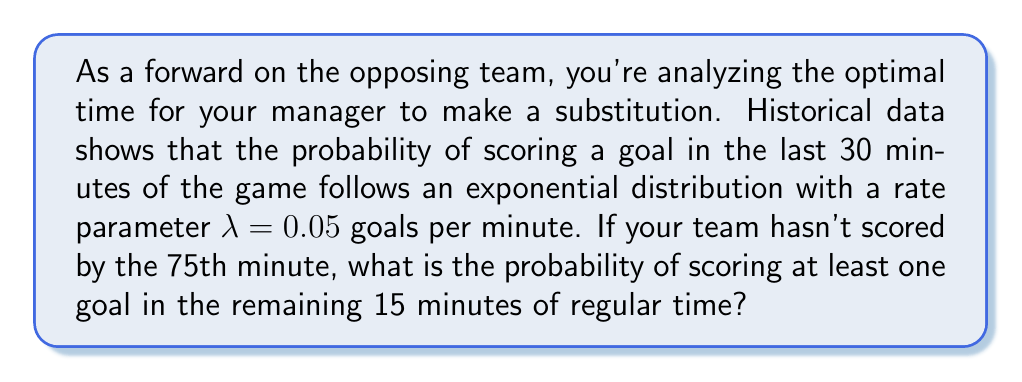Can you solve this math problem? To solve this problem, we need to use the properties of the exponential distribution and probability theory. Let's break it down step-by-step:

1) The exponential distribution models the time between events in a Poisson process. In this case, it models the time between goals.

2) The probability of scoring at least one goal in a given time period is the complement of the probability of scoring no goals in that period.

3) For an exponential distribution with rate parameter $\lambda$, the probability of no events occurring in time $t$ is given by:

   $$P(\text{no events in time } t) = e^{-\lambda t}$$

4) In this case, $\lambda = 0.05$ goals/minute and $t = 15$ minutes.

5) Therefore, the probability of scoring no goals in the last 15 minutes is:

   $$P(\text{no goals}) = e^{-0.05 \cdot 15} = e^{-0.75}$$

6) The probability of scoring at least one goal is the complement of this:

   $$P(\text{at least one goal}) = 1 - P(\text{no goals}) = 1 - e^{-0.75}$$

7) Calculating this:

   $$1 - e^{-0.75} \approx 1 - 0.4724 = 0.5276$$

Thus, the probability of scoring at least one goal in the remaining 15 minutes is approximately 0.5276 or 52.76%.
Answer: The probability of scoring at least one goal in the remaining 15 minutes is approximately 0.5276 or 52.76%. 